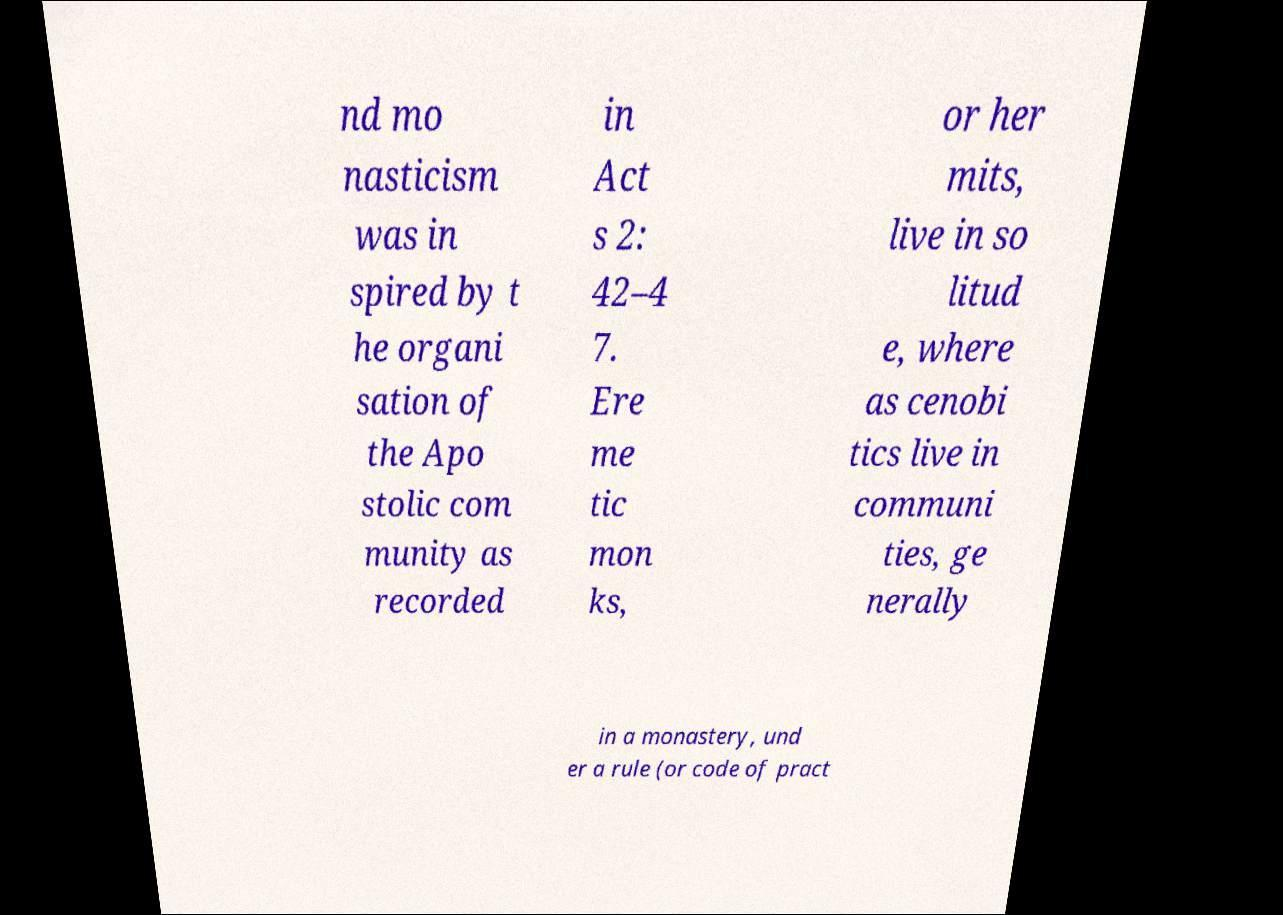Can you accurately transcribe the text from the provided image for me? nd mo nasticism was in spired by t he organi sation of the Apo stolic com munity as recorded in Act s 2: 42–4 7. Ere me tic mon ks, or her mits, live in so litud e, where as cenobi tics live in communi ties, ge nerally in a monastery, und er a rule (or code of pract 